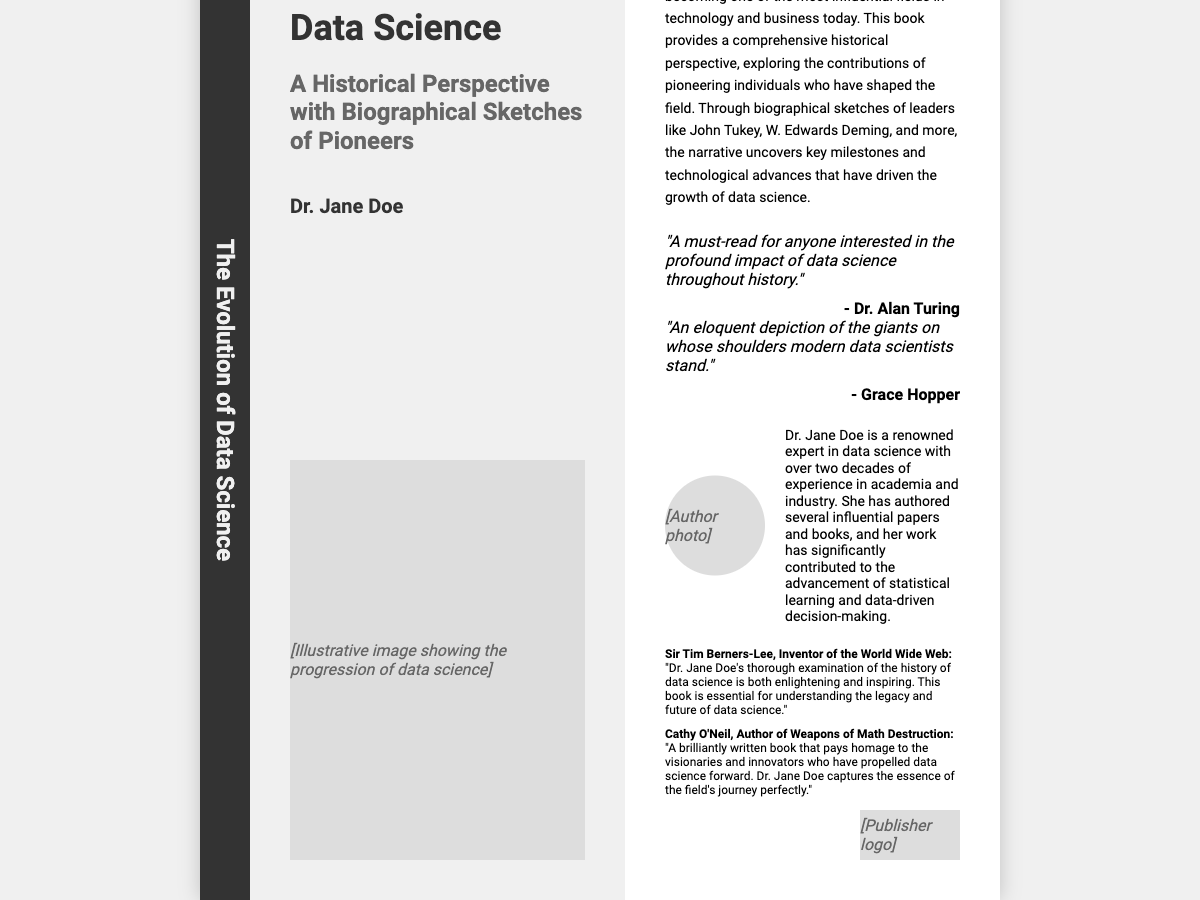What is the title of the book? The title is prominently displayed on the front cover section of the document.
Answer: The Evolution of Data Science Who is the author of the book? The author's name is listed below the title on the front cover.
Answer: Dr. Jane Doe What historical perspective does the book provide? The subtitle of the book indicates the focus on a historical perspective.
Answer: A Historical Perspective with Biographical Sketches of Pioneers Which pioneers are mentioned in the summary? The summary includes specific names of prominent individuals in data science.
Answer: John Tukey, W. Edwards Deming What does Sir Tim Berners-Lee commend the book for? His endorsement mentions what he finds enlightening about the book.
Answer: Thorough examination of the history of data science How many notable quotes are featured in the document? The quotes section includes multiple quotes related to the book.
Answer: Two What type of publication is this document? The structure and content of the document indicate its specific genre.
Answer: Book cover What is depicted in the main image? The description of the main image implies its significance to the book's theme.
Answer: The progression of data science How many decades of experience does the author have? The author bio states the length of the author's experience in the field.
Answer: Over two decades 